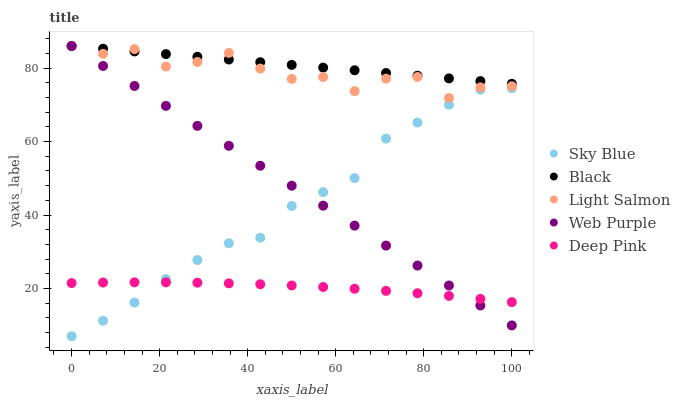Does Deep Pink have the minimum area under the curve?
Answer yes or no. Yes. Does Black have the maximum area under the curve?
Answer yes or no. Yes. Does Light Salmon have the minimum area under the curve?
Answer yes or no. No. Does Light Salmon have the maximum area under the curve?
Answer yes or no. No. Is Web Purple the smoothest?
Answer yes or no. Yes. Is Light Salmon the roughest?
Answer yes or no. Yes. Is Deep Pink the smoothest?
Answer yes or no. No. Is Deep Pink the roughest?
Answer yes or no. No. Does Sky Blue have the lowest value?
Answer yes or no. Yes. Does Light Salmon have the lowest value?
Answer yes or no. No. Does Web Purple have the highest value?
Answer yes or no. Yes. Does Deep Pink have the highest value?
Answer yes or no. No. Is Deep Pink less than Black?
Answer yes or no. Yes. Is Light Salmon greater than Deep Pink?
Answer yes or no. Yes. Does Black intersect Web Purple?
Answer yes or no. Yes. Is Black less than Web Purple?
Answer yes or no. No. Is Black greater than Web Purple?
Answer yes or no. No. Does Deep Pink intersect Black?
Answer yes or no. No. 